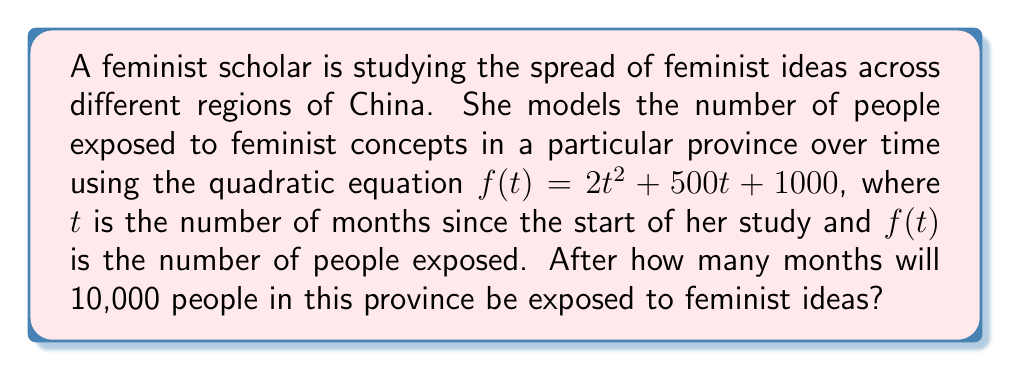What is the answer to this math problem? To solve this problem, we need to follow these steps:

1) We are looking for the time $t$ when $f(t) = 10000$. So, we need to solve the equation:

   $2t^2 + 500t + 1000 = 10000$

2) Subtract 10000 from both sides:

   $2t^2 + 500t - 9000 = 0$

3) This is a quadratic equation in the standard form $at^2 + bt + c = 0$, where:
   $a = 2$, $b = 500$, and $c = -9000$

4) We can solve this using the quadratic formula: $t = \frac{-b \pm \sqrt{b^2 - 4ac}}{2a}$

5) Substituting our values:

   $t = \frac{-500 \pm \sqrt{500^2 - 4(2)(-9000)}}{2(2)}$

6) Simplify:

   $t = \frac{-500 \pm \sqrt{250000 + 72000}}{4} = \frac{-500 \pm \sqrt{322000}}{4}$

7) Calculate:

   $t = \frac{-500 \pm 567.45}{4}$

8) This gives us two solutions:

   $t_1 = \frac{-500 + 567.45}{4} = 16.86$ months
   $t_2 = \frac{-500 - 567.45}{4} = -266.86$ months

9) Since time cannot be negative in this context, we discard the negative solution.

10) Rounding up to the nearest whole month (as we can't have a fractional month), we get 17 months.
Answer: 17 months 